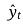Convert formula to latex. <formula><loc_0><loc_0><loc_500><loc_500>\hat { y } _ { t }</formula> 